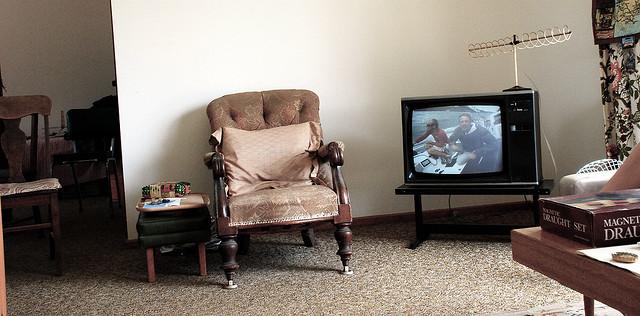Who is sitting in the chair next to the TV?
Answer briefly. No one. Is the TV on?
Be succinct. Yes. What sort of television set is this?
Keep it brief. Old. 